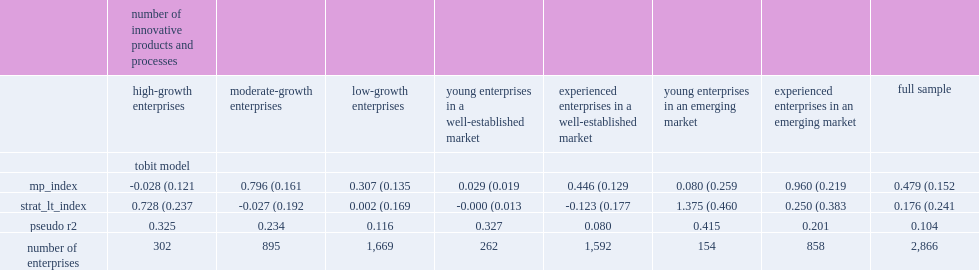Would you mind parsing the complete table? {'header': ['', 'number of innovative products and processes', '', '', '', '', '', '', ''], 'rows': [['', 'high-growth enterprises', 'moderate-growth enterprises', 'low-growth enterprises', 'young enterprises in a well-established market', 'experienced enterprises in a well-established market', 'young enterprises in an emerging market', 'experienced enterprises in an emerging market', 'full sample'], ['', 'tobit model', '', '', '', '', '', '', ''], ['mp_index', '-0.028 (0.121', '0.796 (0.161', '0.307 (0.135', '0.029 (0.019', '0.446 (0.129', '0.080 (0.259', '0.960 (0.219', '0.479 (0.152'], ['strat_lt_index', '0.728 (0.237', '-0.027 (0.192', '0.002 (0.169', '-0.000 (0.013', '-0.123 (0.177', '1.375 (0.460', '0.250 (0.383', '0.176 (0.241'], ['pseudo r2', '0.325', '0.234', '0.116', '0.327', '0.080', '0.415', '0.201', '0.104'], ['number of enterprises', '302', '895', '1,669', '262', '1,592', '154', '858', '2,866']]} How many percent increase in the number of product or process innovations can a one-point increase in the management practices index causes for the full sample? 0.479 (0.152. How many percent increase in the number of product or process innovations can good management practices causes for experienced enterprises operating in emerging markets (of_ext)? 0.960 (0.219. How many percent average number of innovative products and processes can a one-point increase in the long-term strategic directions index causes for high-growth enterprises? 0.728 (0.237. 